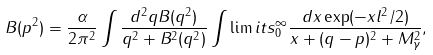<formula> <loc_0><loc_0><loc_500><loc_500>B ( p ^ { 2 } ) = \frac { \alpha } { 2 \pi ^ { 2 } } \int \frac { d ^ { 2 } q B ( q ^ { 2 } ) } { q ^ { 2 } + B ^ { 2 } ( q ^ { 2 } ) } \int \lim i t s _ { 0 } ^ { \infty } \frac { d x \exp ( - x l ^ { 2 } / 2 ) } { x + ( { q } - { p } ) ^ { 2 } + M _ { \gamma } ^ { 2 } } ,</formula> 